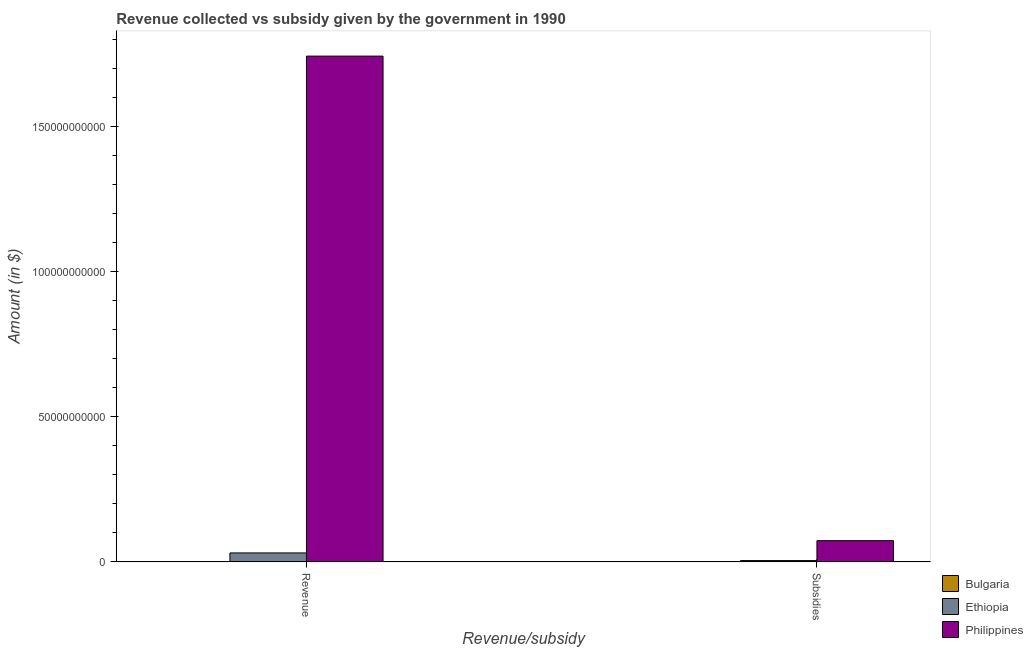How many different coloured bars are there?
Your response must be concise. 3. How many groups of bars are there?
Offer a terse response. 2. Are the number of bars per tick equal to the number of legend labels?
Provide a short and direct response. Yes. Are the number of bars on each tick of the X-axis equal?
Your answer should be compact. Yes. How many bars are there on the 2nd tick from the left?
Offer a terse response. 3. What is the label of the 1st group of bars from the left?
Give a very brief answer. Revenue. What is the amount of revenue collected in Ethiopia?
Your response must be concise. 3.09e+09. Across all countries, what is the maximum amount of subsidies given?
Make the answer very short. 7.31e+09. Across all countries, what is the minimum amount of revenue collected?
Offer a very short reply. 2.14e+07. In which country was the amount of revenue collected minimum?
Your answer should be compact. Bulgaria. What is the total amount of subsidies given in the graph?
Your answer should be compact. 7.78e+09. What is the difference between the amount of subsidies given in Ethiopia and that in Bulgaria?
Your response must be concise. 4.41e+08. What is the difference between the amount of subsidies given in Ethiopia and the amount of revenue collected in Philippines?
Your answer should be very brief. -1.74e+11. What is the average amount of revenue collected per country?
Ensure brevity in your answer.  5.91e+1. What is the difference between the amount of subsidies given and amount of revenue collected in Bulgaria?
Provide a succinct answer. -8.41e+06. What is the ratio of the amount of revenue collected in Philippines to that in Bulgaria?
Give a very brief answer. 8138.5. What does the 3rd bar from the left in Revenue represents?
Offer a very short reply. Philippines. What does the 3rd bar from the right in Revenue represents?
Your answer should be compact. Bulgaria. How many countries are there in the graph?
Ensure brevity in your answer.  3. Are the values on the major ticks of Y-axis written in scientific E-notation?
Ensure brevity in your answer.  No. Does the graph contain grids?
Ensure brevity in your answer.  No. What is the title of the graph?
Make the answer very short. Revenue collected vs subsidy given by the government in 1990. What is the label or title of the X-axis?
Provide a succinct answer. Revenue/subsidy. What is the label or title of the Y-axis?
Make the answer very short. Amount (in $). What is the Amount (in $) in Bulgaria in Revenue?
Make the answer very short. 2.14e+07. What is the Amount (in $) of Ethiopia in Revenue?
Give a very brief answer. 3.09e+09. What is the Amount (in $) in Philippines in Revenue?
Your answer should be compact. 1.74e+11. What is the Amount (in $) in Bulgaria in Subsidies?
Make the answer very short. 1.30e+07. What is the Amount (in $) of Ethiopia in Subsidies?
Your response must be concise. 4.54e+08. What is the Amount (in $) of Philippines in Subsidies?
Your answer should be very brief. 7.31e+09. Across all Revenue/subsidy, what is the maximum Amount (in $) of Bulgaria?
Your answer should be compact. 2.14e+07. Across all Revenue/subsidy, what is the maximum Amount (in $) of Ethiopia?
Provide a short and direct response. 3.09e+09. Across all Revenue/subsidy, what is the maximum Amount (in $) of Philippines?
Your answer should be compact. 1.74e+11. Across all Revenue/subsidy, what is the minimum Amount (in $) of Bulgaria?
Your answer should be compact. 1.30e+07. Across all Revenue/subsidy, what is the minimum Amount (in $) in Ethiopia?
Offer a very short reply. 4.54e+08. Across all Revenue/subsidy, what is the minimum Amount (in $) in Philippines?
Offer a very short reply. 7.31e+09. What is the total Amount (in $) of Bulgaria in the graph?
Your answer should be very brief. 3.44e+07. What is the total Amount (in $) in Ethiopia in the graph?
Your answer should be very brief. 3.55e+09. What is the total Amount (in $) of Philippines in the graph?
Your answer should be very brief. 1.81e+11. What is the difference between the Amount (in $) of Bulgaria in Revenue and that in Subsidies?
Keep it short and to the point. 8.41e+06. What is the difference between the Amount (in $) in Ethiopia in Revenue and that in Subsidies?
Make the answer very short. 2.64e+09. What is the difference between the Amount (in $) of Philippines in Revenue and that in Subsidies?
Your response must be concise. 1.67e+11. What is the difference between the Amount (in $) of Bulgaria in Revenue and the Amount (in $) of Ethiopia in Subsidies?
Provide a succinct answer. -4.33e+08. What is the difference between the Amount (in $) of Bulgaria in Revenue and the Amount (in $) of Philippines in Subsidies?
Give a very brief answer. -7.29e+09. What is the difference between the Amount (in $) in Ethiopia in Revenue and the Amount (in $) in Philippines in Subsidies?
Provide a short and direct response. -4.22e+09. What is the average Amount (in $) of Bulgaria per Revenue/subsidy?
Provide a succinct answer. 1.72e+07. What is the average Amount (in $) of Ethiopia per Revenue/subsidy?
Provide a short and direct response. 1.77e+09. What is the average Amount (in $) in Philippines per Revenue/subsidy?
Keep it short and to the point. 9.07e+1. What is the difference between the Amount (in $) of Bulgaria and Amount (in $) of Ethiopia in Revenue?
Your answer should be compact. -3.07e+09. What is the difference between the Amount (in $) in Bulgaria and Amount (in $) in Philippines in Revenue?
Your response must be concise. -1.74e+11. What is the difference between the Amount (in $) of Ethiopia and Amount (in $) of Philippines in Revenue?
Your answer should be compact. -1.71e+11. What is the difference between the Amount (in $) of Bulgaria and Amount (in $) of Ethiopia in Subsidies?
Make the answer very short. -4.41e+08. What is the difference between the Amount (in $) in Bulgaria and Amount (in $) in Philippines in Subsidies?
Offer a terse response. -7.30e+09. What is the difference between the Amount (in $) of Ethiopia and Amount (in $) of Philippines in Subsidies?
Ensure brevity in your answer.  -6.86e+09. What is the ratio of the Amount (in $) of Bulgaria in Revenue to that in Subsidies?
Give a very brief answer. 1.65. What is the ratio of the Amount (in $) of Ethiopia in Revenue to that in Subsidies?
Make the answer very short. 6.81. What is the ratio of the Amount (in $) of Philippines in Revenue to that in Subsidies?
Make the answer very short. 23.83. What is the difference between the highest and the second highest Amount (in $) of Bulgaria?
Give a very brief answer. 8.41e+06. What is the difference between the highest and the second highest Amount (in $) in Ethiopia?
Offer a very short reply. 2.64e+09. What is the difference between the highest and the second highest Amount (in $) of Philippines?
Make the answer very short. 1.67e+11. What is the difference between the highest and the lowest Amount (in $) in Bulgaria?
Provide a short and direct response. 8.41e+06. What is the difference between the highest and the lowest Amount (in $) of Ethiopia?
Offer a very short reply. 2.64e+09. What is the difference between the highest and the lowest Amount (in $) of Philippines?
Your answer should be very brief. 1.67e+11. 